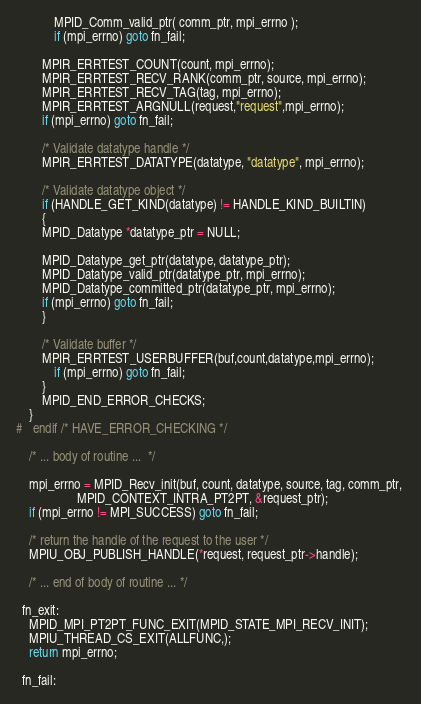<code> <loc_0><loc_0><loc_500><loc_500><_C_>            MPID_Comm_valid_ptr( comm_ptr, mpi_errno );
            if (mpi_errno) goto fn_fail;
	    
	    MPIR_ERRTEST_COUNT(count, mpi_errno);
	    MPIR_ERRTEST_RECV_RANK(comm_ptr, source, mpi_errno);
	    MPIR_ERRTEST_RECV_TAG(tag, mpi_errno);
	    MPIR_ERRTEST_ARGNULL(request,"request",mpi_errno);
	    if (mpi_errno) goto fn_fail;

	    /* Validate datatype handle */
	    MPIR_ERRTEST_DATATYPE(datatype, "datatype", mpi_errno);
	    
	    /* Validate datatype object */
	    if (HANDLE_GET_KIND(datatype) != HANDLE_KIND_BUILTIN)
	    {
		MPID_Datatype *datatype_ptr = NULL;

		MPID_Datatype_get_ptr(datatype, datatype_ptr);
		MPID_Datatype_valid_ptr(datatype_ptr, mpi_errno);
		MPID_Datatype_committed_ptr(datatype_ptr, mpi_errno);
		if (mpi_errno) goto fn_fail;
	    }
	    
	    /* Validate buffer */
	    MPIR_ERRTEST_USERBUFFER(buf,count,datatype,mpi_errno);
            if (mpi_errno) goto fn_fail;
        }
        MPID_END_ERROR_CHECKS;
    }
#   endif /* HAVE_ERROR_CHECKING */

    /* ... body of routine ...  */
    
    mpi_errno = MPID_Recv_init(buf, count, datatype, source, tag, comm_ptr, 
			       MPID_CONTEXT_INTRA_PT2PT, &request_ptr);
    if (mpi_errno != MPI_SUCCESS) goto fn_fail;

    /* return the handle of the request to the user */
    MPIU_OBJ_PUBLISH_HANDLE(*request, request_ptr->handle);

    /* ... end of body of routine ... */
    
  fn_exit:
    MPID_MPI_PT2PT_FUNC_EXIT(MPID_STATE_MPI_RECV_INIT);
    MPIU_THREAD_CS_EXIT(ALLFUNC,);
    return mpi_errno;

  fn_fail:</code> 